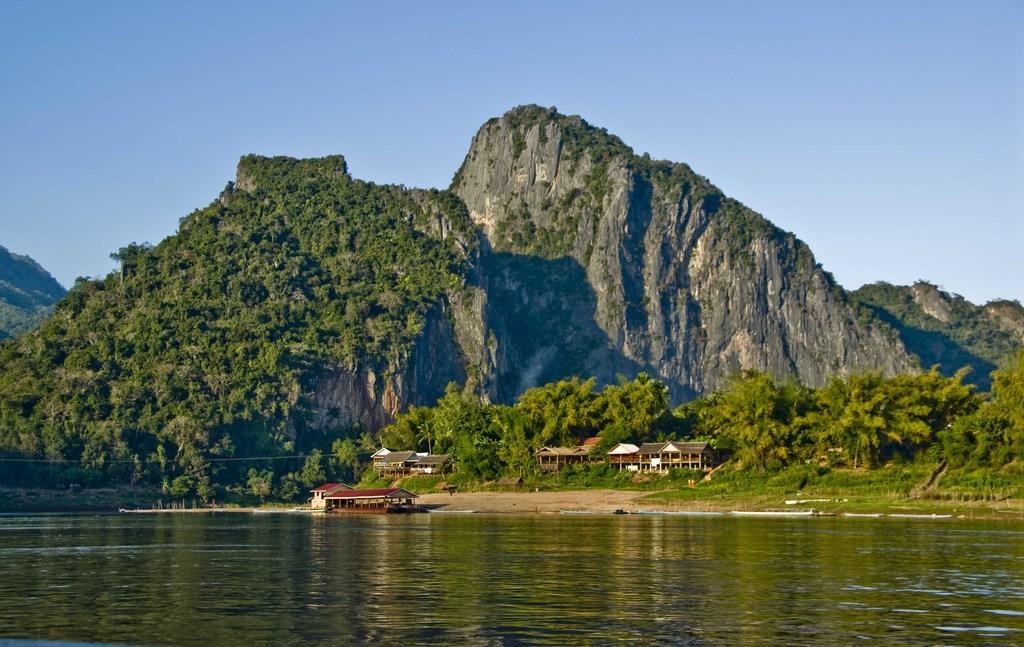How would you summarize this image in a sentence or two? There are mountains covered with trees. At the bottom there is river. Image also consists of houses and many trees. At the top there is sky. 